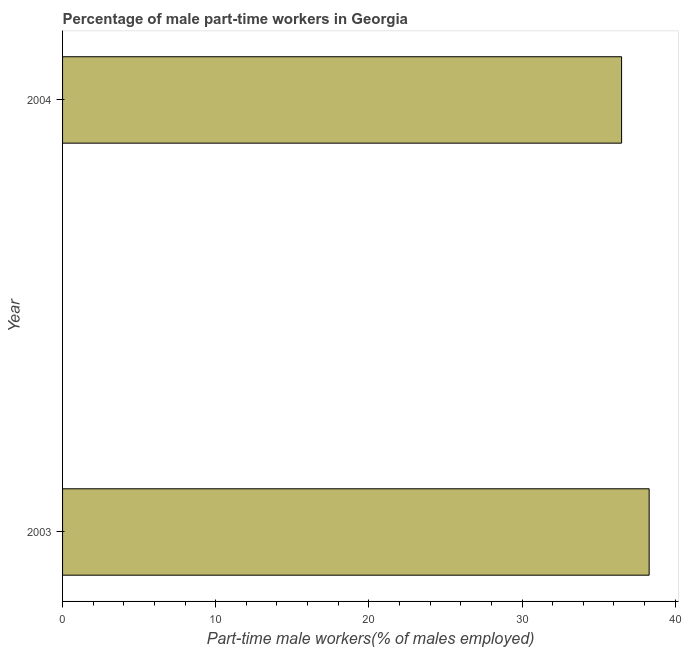Does the graph contain any zero values?
Give a very brief answer. No. What is the title of the graph?
Offer a very short reply. Percentage of male part-time workers in Georgia. What is the label or title of the X-axis?
Your answer should be very brief. Part-time male workers(% of males employed). What is the percentage of part-time male workers in 2003?
Make the answer very short. 38.3. Across all years, what is the maximum percentage of part-time male workers?
Make the answer very short. 38.3. Across all years, what is the minimum percentage of part-time male workers?
Your response must be concise. 36.5. What is the sum of the percentage of part-time male workers?
Provide a short and direct response. 74.8. What is the average percentage of part-time male workers per year?
Make the answer very short. 37.4. What is the median percentage of part-time male workers?
Provide a succinct answer. 37.4. In how many years, is the percentage of part-time male workers greater than 10 %?
Keep it short and to the point. 2. What is the ratio of the percentage of part-time male workers in 2003 to that in 2004?
Keep it short and to the point. 1.05. In how many years, is the percentage of part-time male workers greater than the average percentage of part-time male workers taken over all years?
Your answer should be very brief. 1. How many bars are there?
Give a very brief answer. 2. Are all the bars in the graph horizontal?
Keep it short and to the point. Yes. How many years are there in the graph?
Make the answer very short. 2. What is the difference between two consecutive major ticks on the X-axis?
Offer a terse response. 10. What is the Part-time male workers(% of males employed) of 2003?
Make the answer very short. 38.3. What is the Part-time male workers(% of males employed) of 2004?
Ensure brevity in your answer.  36.5. What is the ratio of the Part-time male workers(% of males employed) in 2003 to that in 2004?
Ensure brevity in your answer.  1.05. 